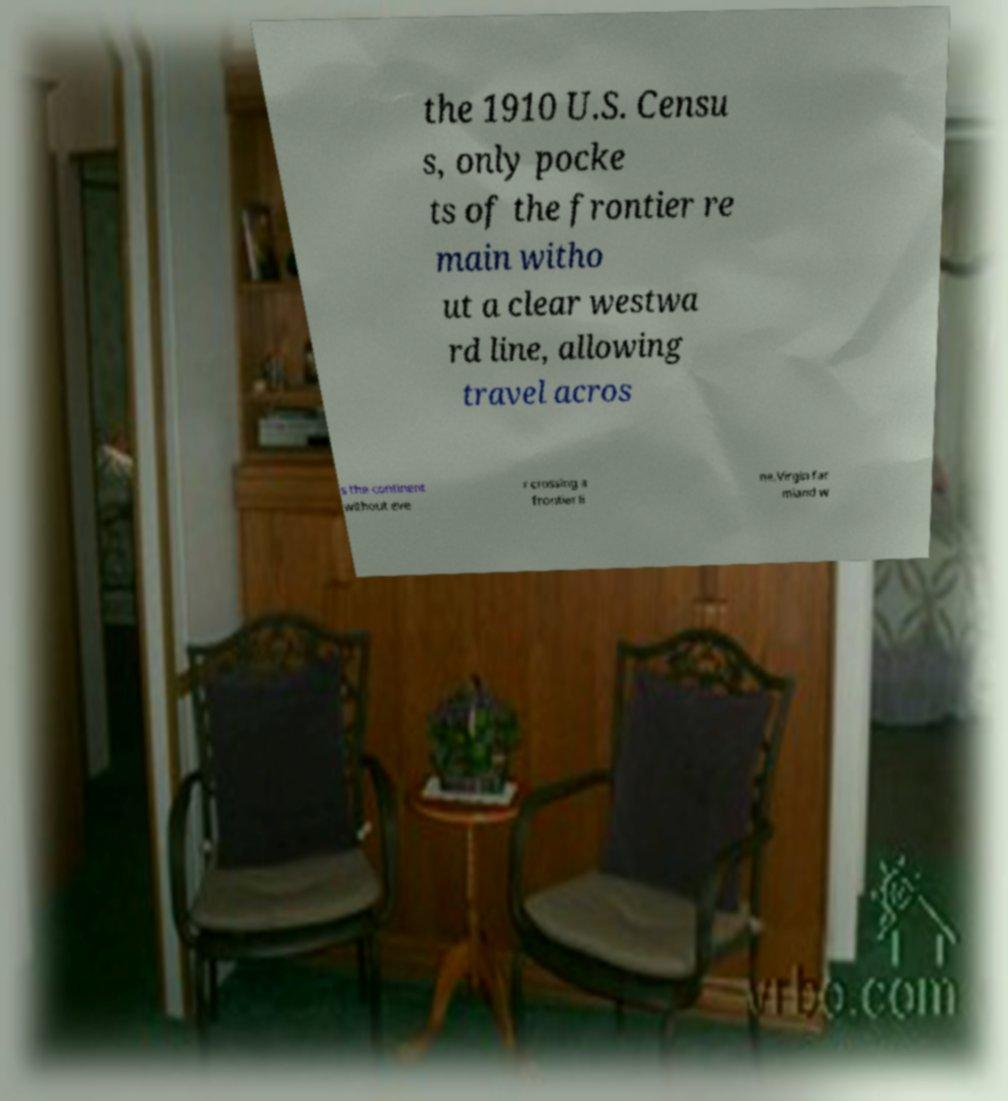Could you extract and type out the text from this image? the 1910 U.S. Censu s, only pocke ts of the frontier re main witho ut a clear westwa rd line, allowing travel acros s the continent without eve r crossing a frontier li ne.Virgin far mland w 